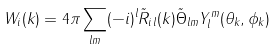Convert formula to latex. <formula><loc_0><loc_0><loc_500><loc_500>W _ { i } ( { k } ) = 4 \pi \sum _ { l m } ( - i ) ^ { l } \tilde { R } _ { i \, l } ( k ) \tilde { \Theta } _ { l m } Y _ { l } ^ { m } ( \theta _ { k } , \phi _ { k } )</formula> 